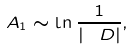<formula> <loc_0><loc_0><loc_500><loc_500>A _ { 1 } \sim \ln \frac { 1 } { | \ D | } ,</formula> 